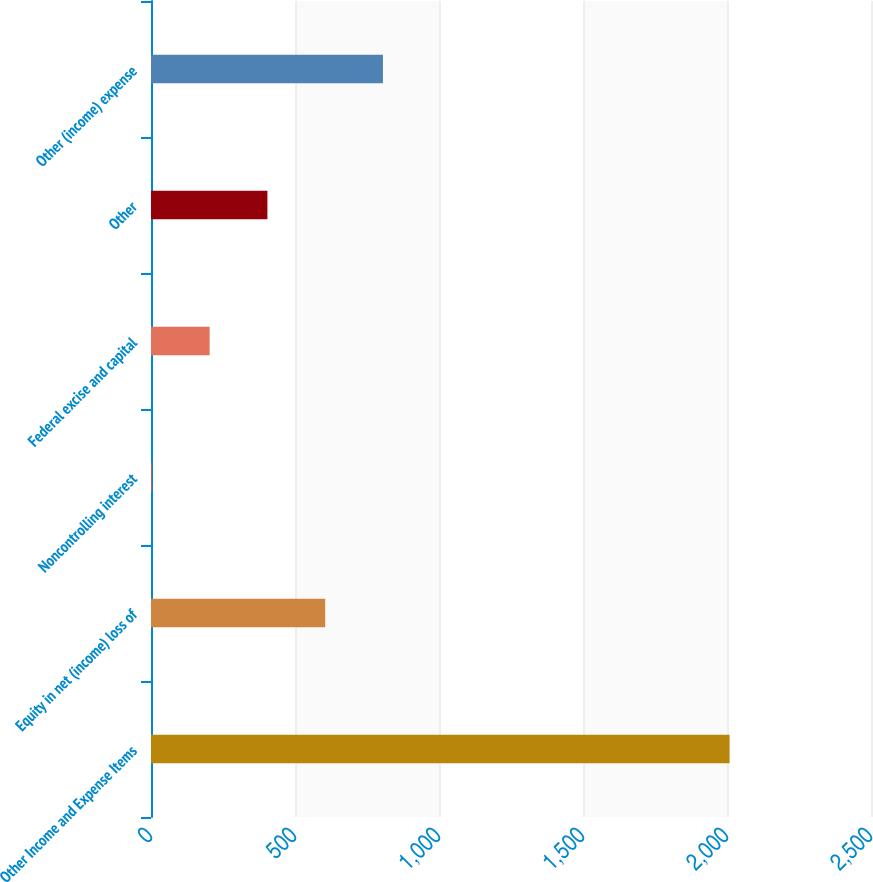Convert chart to OTSL. <chart><loc_0><loc_0><loc_500><loc_500><bar_chart><fcel>Other Income and Expense Items<fcel>Equity in net (income) loss of<fcel>Noncontrolling interest<fcel>Federal excise and capital<fcel>Other<fcel>Other (income) expense<nl><fcel>2009<fcel>604.8<fcel>3<fcel>203.6<fcel>404.2<fcel>805.4<nl></chart> 